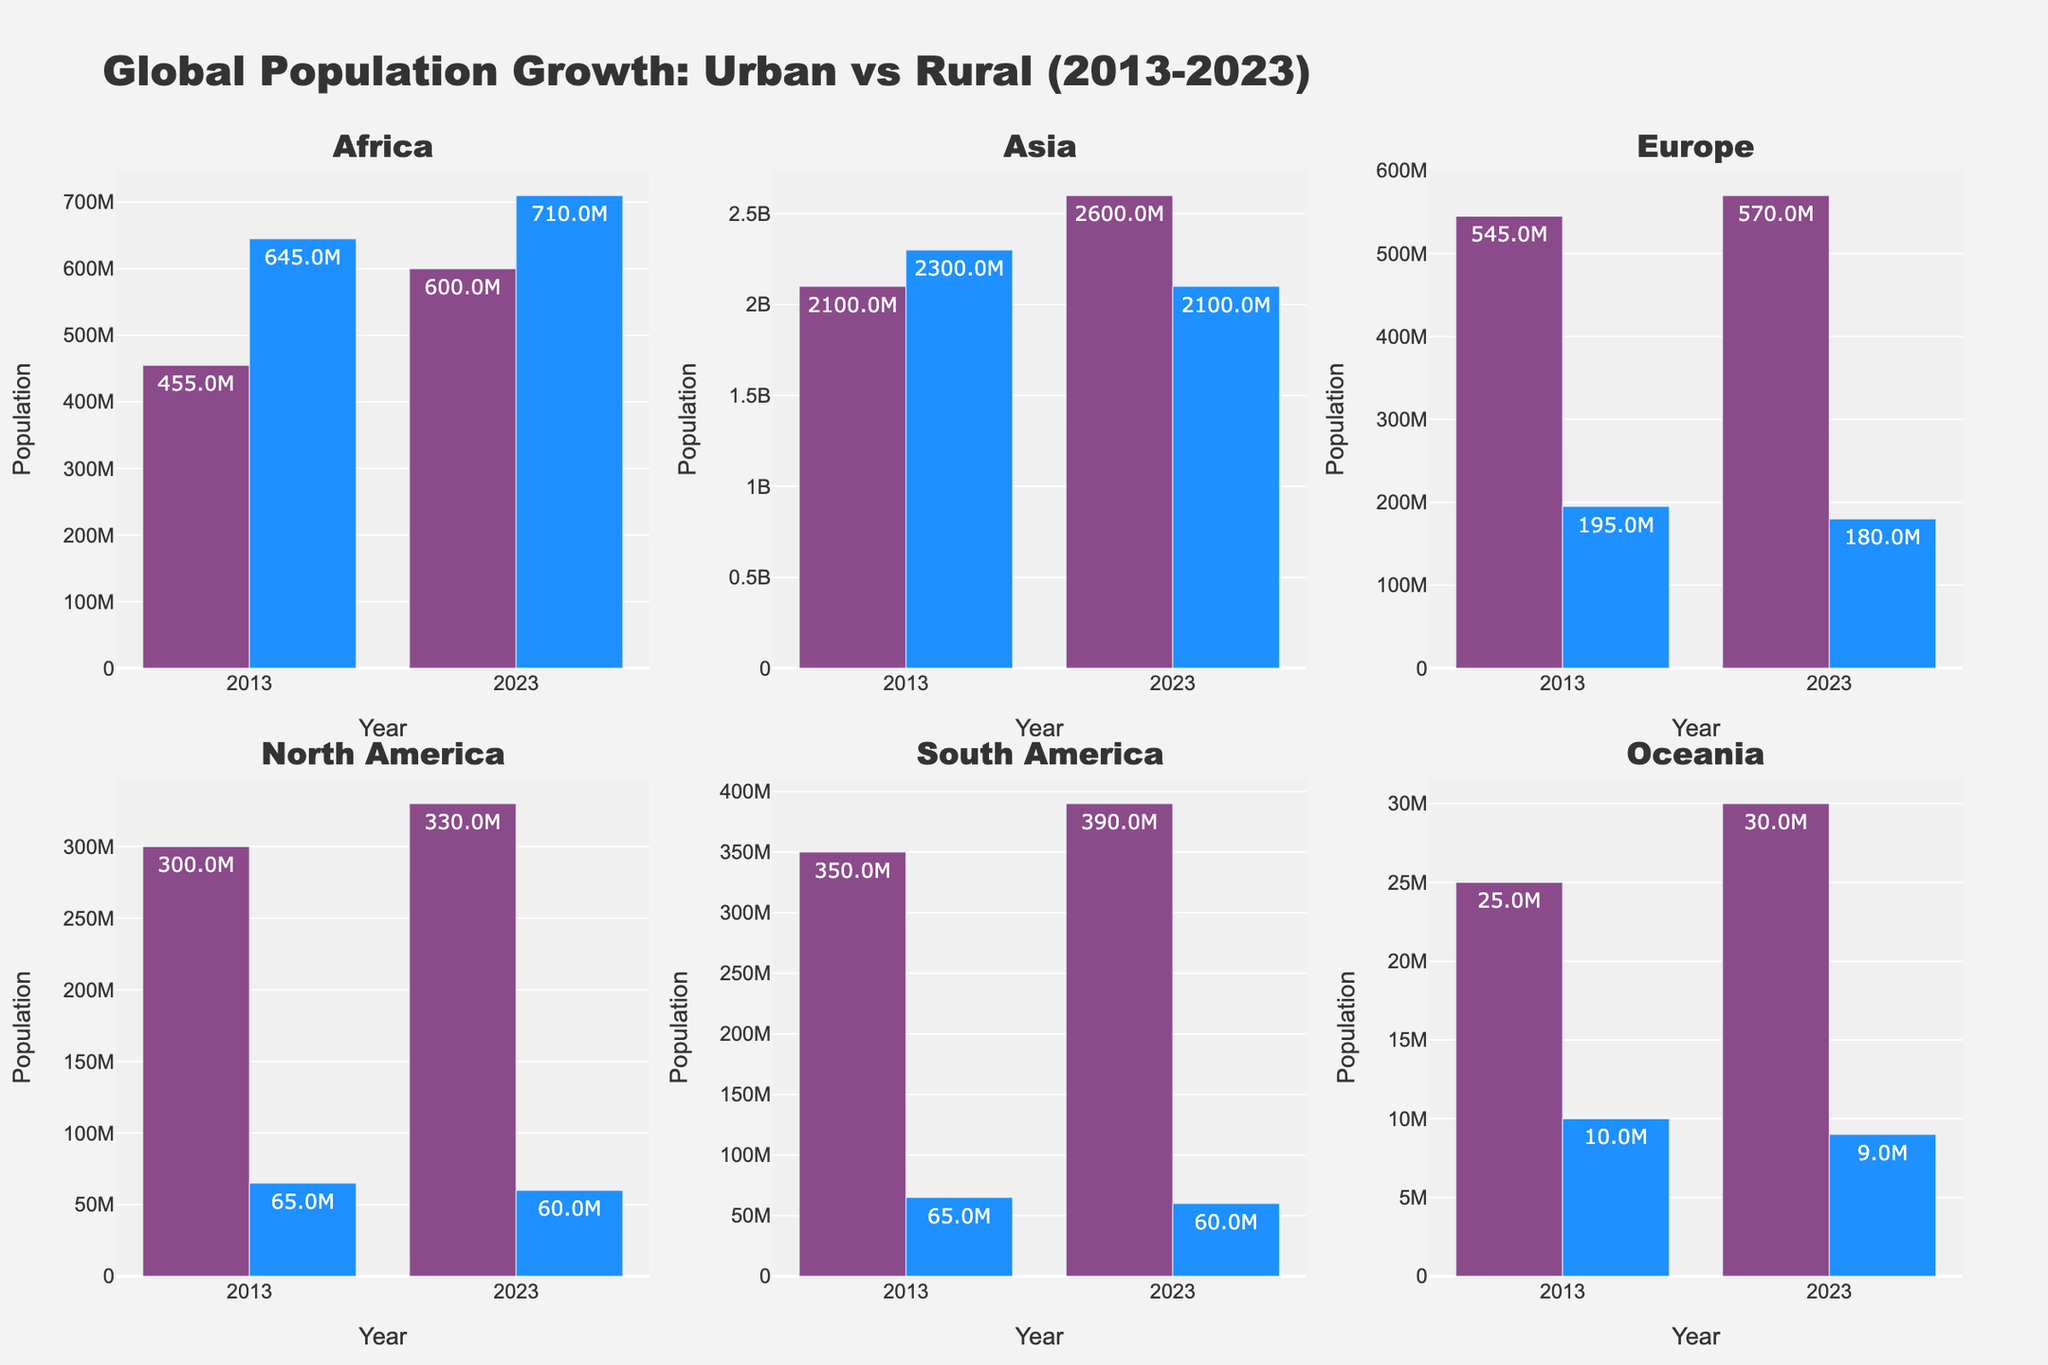What is the title of the plot? The title is located at the top center of the plot and indicates the subject of the figure. The title reads "Global Population Growth: Urban vs Rural (2013-2023)", which describes the changes in urban and rural populations over a decade.
Answer: Global Population Growth: Urban vs Rural (2013-2023) Which continent experienced the largest increase in urban population from 2013 to 2023? To find the continent with the largest increase, subtract the 2013 urban population from the 2023 urban population for each continent. Africa went from 455M to 600M (145M increase), Asia from 2100M to 2600M (500M increase), Europe from 545M to 570M (25M increase), North America from 300M to 330M (30M increase), South America from 350M to 390M (40M increase), and Oceania from 25M to 30M (5M increase). The largest change is in Asia.
Answer: Asia What are the urban and rural population values for Europe in 2013? Find the subplot for Europe and look at the bar heights and text annotations for the year 2013. The urban population is shown as 545M and the rural population as 195M.
Answer: Urban: 545M, Rural: 195M Which continent had the highest rural population in 2023? Examine the rural bars for the year 2023 in each subplot. Asia has the highest bar among all continents with a rural population of 2100M in 2023.
Answer: Asia How much did the rural population decrease in Europe between 2013 and 2023? Subtract the rural population of Europe in 2023 (180M) from its population in 2013 (195M): 195M - 180M = 15M.
Answer: 15M Comparing the urban and rural population shifts in North America from 2013 to 2023, which one grew more significantly? North America’s urban population grew from 300M to 330M, an increase of 30M, whereas the rural population decreased from 65M to 60M, a decrease of 5M. The urban population grew more significantly.
Answer: Urban Which continent shows a decrease in both urban and rural populations from 2013 to 2023? Look for a continent where both the urban and rural bars decrease over the years. Only Europe shows a decrease in rural population (195M to 180M) while its urban population slightly increased (545M to 570M). Hence, no continent shows a decrease in both urban and rural populations.
Answer: None Which two continents have the smallest urban population in 2023? Check the heights and text annotations for the urban populations in 2023 across all subplots. Oceania (30M) and North America (330M) have the smallest urban populations.
Answer: Oceania and North America How did the rural population in Africa change from 2013 to 2023? Look at the differences between the rural population bars for Africa in 2013 (645M) and 2023 (710M). The rural population increased by 65M (710M - 645M).
Answer: Increased by 65M 